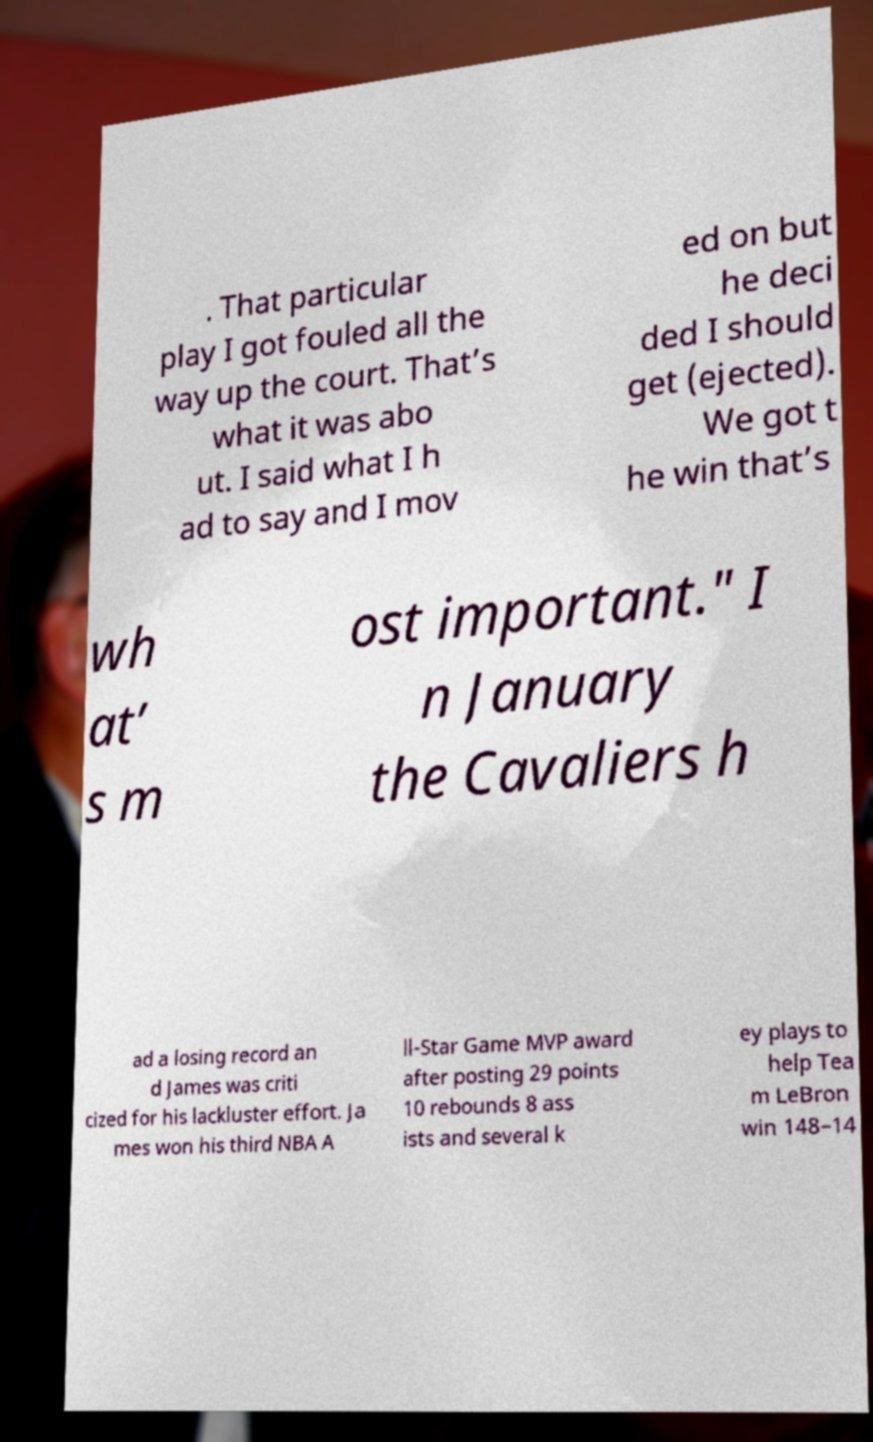Could you extract and type out the text from this image? . That particular play I got fouled all the way up the court. That’s what it was abo ut. I said what I h ad to say and I mov ed on but he deci ded I should get (ejected). We got t he win that’s wh at’ s m ost important." I n January the Cavaliers h ad a losing record an d James was criti cized for his lackluster effort. Ja mes won his third NBA A ll-Star Game MVP award after posting 29 points 10 rebounds 8 ass ists and several k ey plays to help Tea m LeBron win 148–14 